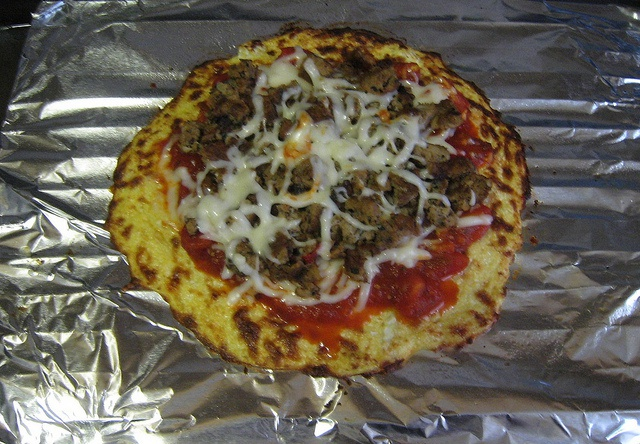Describe the objects in this image and their specific colors. I can see a pizza in black, maroon, and olive tones in this image. 